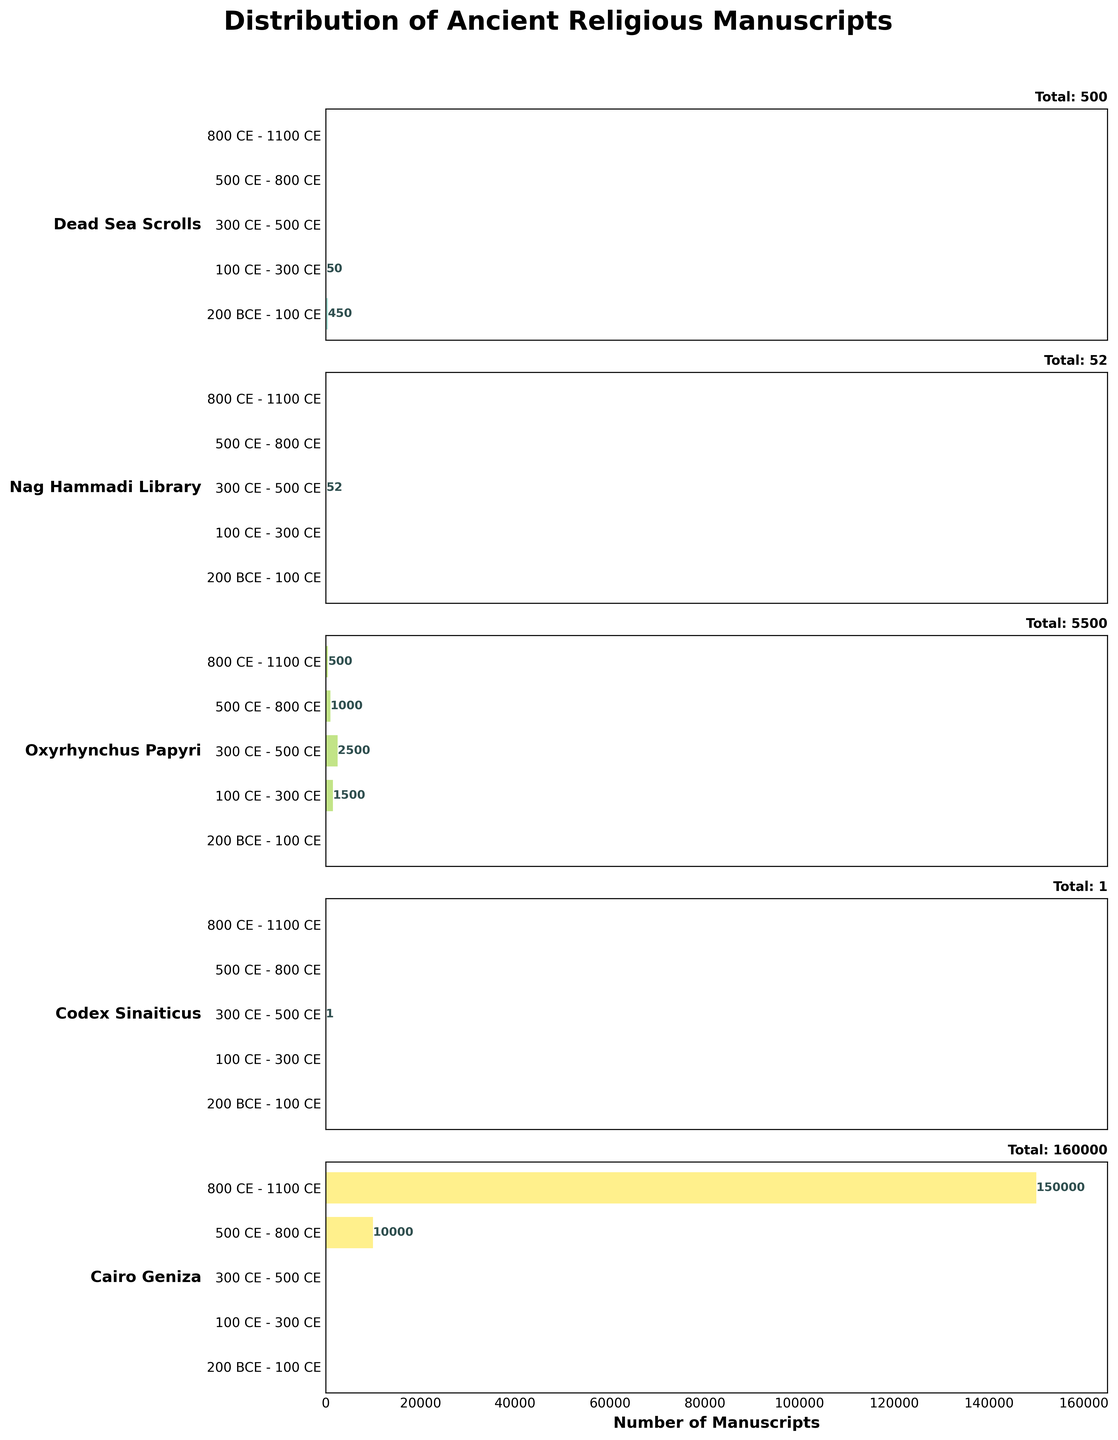What is the title of the figure? The title of the figure placed at the top center is 'Distribution of Ancient Religious Manuscripts'. Titles usually provide a succinct summary of what the figure is about.
Answer: Distribution of Ancient Religious Manuscripts For which time period were the Oxyrhynchus Papyri most numerous? To find the time period when Oxyrhynchus Papyri were most numerous, we look at the horizontal bars for the Oxyrhynchus Papyri subplot. The longest bar corresponds to the 300 CE - 500 CE period.
Answer: 300 CE - 500 CE How many Dead Sea Scrolls were found between 200 BCE and 100 CE? Each subplot represents a different manuscript. The Dead Sea Scrolls subplot shows a bar at 200 BCE - 100 CE with a value of 450, which corresponds to the number.
Answer: 450 Which manuscript has the highest total number of manuscripts found across all time periods? From the titles on the right side of each subplot, we see the total manuscript count. The Cairo Geniza has the highest total with 160,000.
Answer: Cairo Geniza What is the combined number of manuscripts found in the Cairo Geniza and Codex Sinaiticus for the 500 CE - 800 CE period? Add the values from the Cairo Geniza (10,000) and Codex Sinaiticus (0) for the 500 CE - 800 CE time period. The sum is 10,000.
Answer: 10,000 During which time period were no manuscripts found for the Nag Hammadi Library? Check each time period in the Nag Hammadi Library subplot for zero values. Both 200 BCE - 100 CE, 100 CE - 300 CE, 500 CE - 800 CE, and 800 CE - 1100 CE show no manuscripts, i.e. values are 0.
Answer: 200 BCE - 100 CE, 100 CE - 300 CE, 500 CE - 800 CE, 800 CE - 1100 CE Compare the number of manuscripts found in the Oxyrhynchus Papyri and the Cairo Geniza between 800 CE - 1100 CE. Which one had more? Looking at the 800 CE - 1100 CE period in both subplots, Oxyrhynchus Papyri has 500 manuscripts while Cairo Geniza has 150,000 manuscripts. Therefore, Cairo Geniza has more.
Answer: Cairo Geniza What is the total number of manuscripts found across all time periods for the Codex Sinaiticus? Add up the values from each time period: 0 (200 BCE - 100 CE) + 0 (100 CE - 300 CE) + 1 (300 CE - 500 CE) + 0 (500 CE - 800 CE) + 0 (800 CE - 1100 CE) = 1.
Answer: 1 